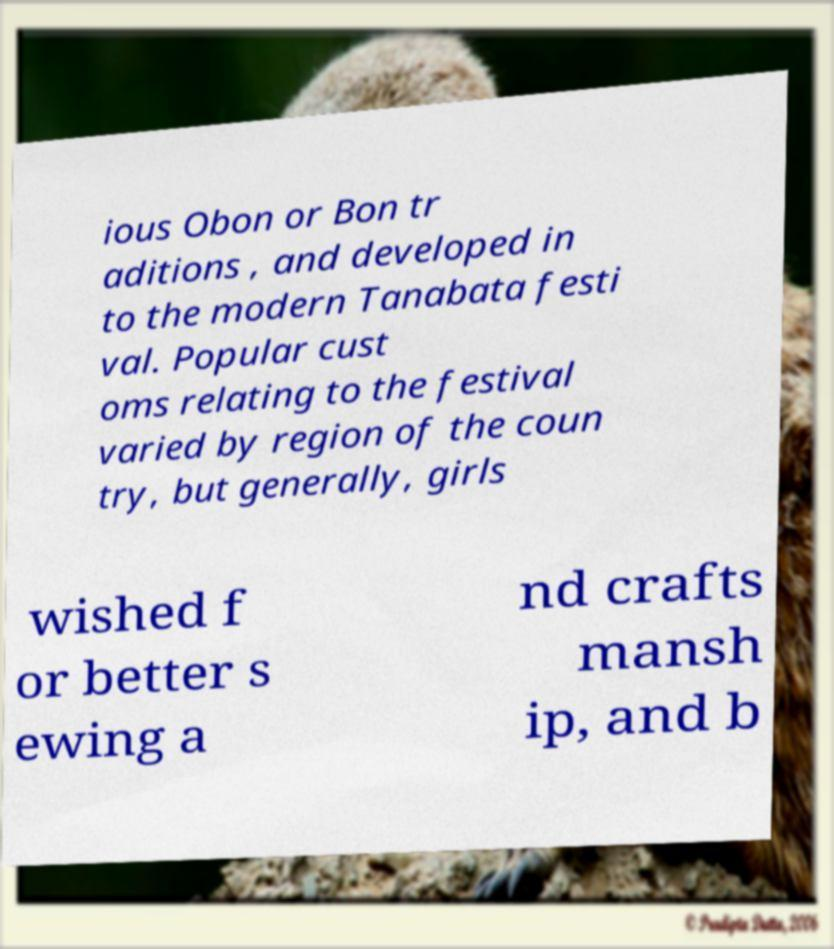Can you accurately transcribe the text from the provided image for me? ious Obon or Bon tr aditions , and developed in to the modern Tanabata festi val. Popular cust oms relating to the festival varied by region of the coun try, but generally, girls wished f or better s ewing a nd crafts mansh ip, and b 